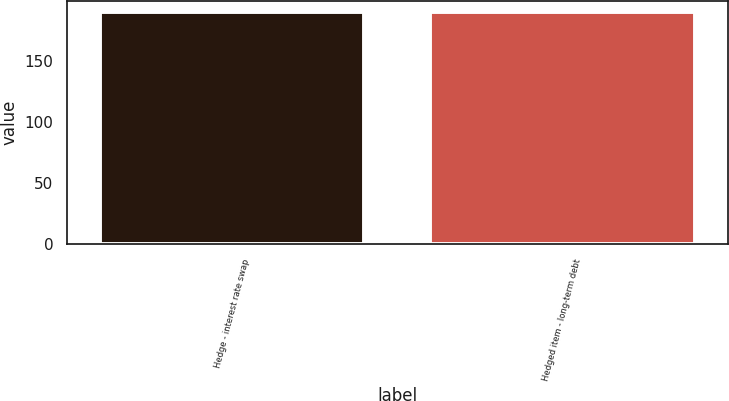Convert chart. <chart><loc_0><loc_0><loc_500><loc_500><bar_chart><fcel>Hedge - interest rate swap<fcel>Hedged item - long-term debt<nl><fcel>190<fcel>190.1<nl></chart> 